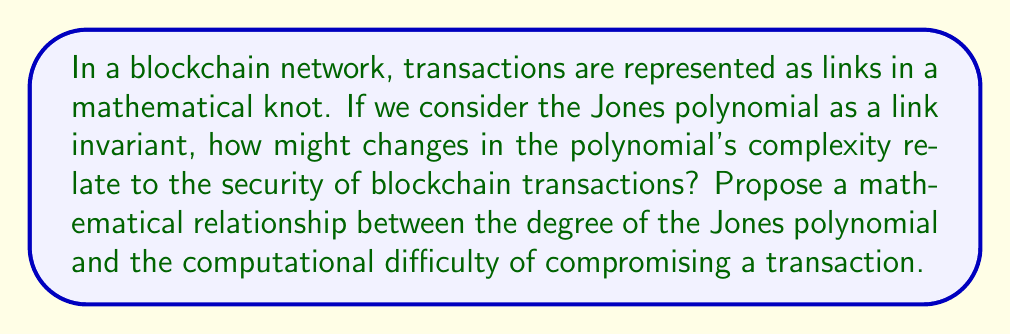Can you solve this math problem? To approach this problem, let's break it down into steps:

1. Recall that the Jones polynomial $V_L(t)$ is a link invariant that assigns a Laurent polynomial in $t^{\frac{1}{2}}$ to each oriented link $L$.

2. The degree of the Jones polynomial can be related to the complexity of the link. In our blockchain analogy, a more complex link (transaction) would have a higher degree polynomial.

3. Let's define $d(L)$ as the degree of the Jones polynomial for a link $L$ representing a blockchain transaction.

4. We can propose that the computational difficulty $C(L)$ of compromising a transaction is exponentially related to the degree of its Jones polynomial:

   $$C(L) = k \cdot 2^{d(L)}$$

   where $k$ is a constant factor representing the base difficulty of compromising a transaction.

5. This relationship suggests that as the degree of the Jones polynomial increases linearly, the computational difficulty increases exponentially.

6. To make this more concrete, let's consider a simple example. Suppose we have two transactions:
   - Transaction A with $d(L_A) = 3$
   - Transaction B with $d(L_B) = 4$

7. The relative difficulty of compromising these transactions would be:

   $$\frac{C(L_B)}{C(L_A)} = \frac{k \cdot 2^4}{k \cdot 2^3} = 2$$

8. This means that Transaction B is twice as difficult to compromise as Transaction A.

9. From an economic perspective, this relationship implies that increasing the complexity of blockchain transactions (as measured by the Jones polynomial) leads to exponential increases in security, but potentially at the cost of increased computational resources for legitimate processing.
Answer: $C(L) = k \cdot 2^{d(L)}$, where $C(L)$ is the computational difficulty of compromising a transaction, $k$ is a constant, and $d(L)$ is the degree of the Jones polynomial for the link $L$ representing the transaction. 